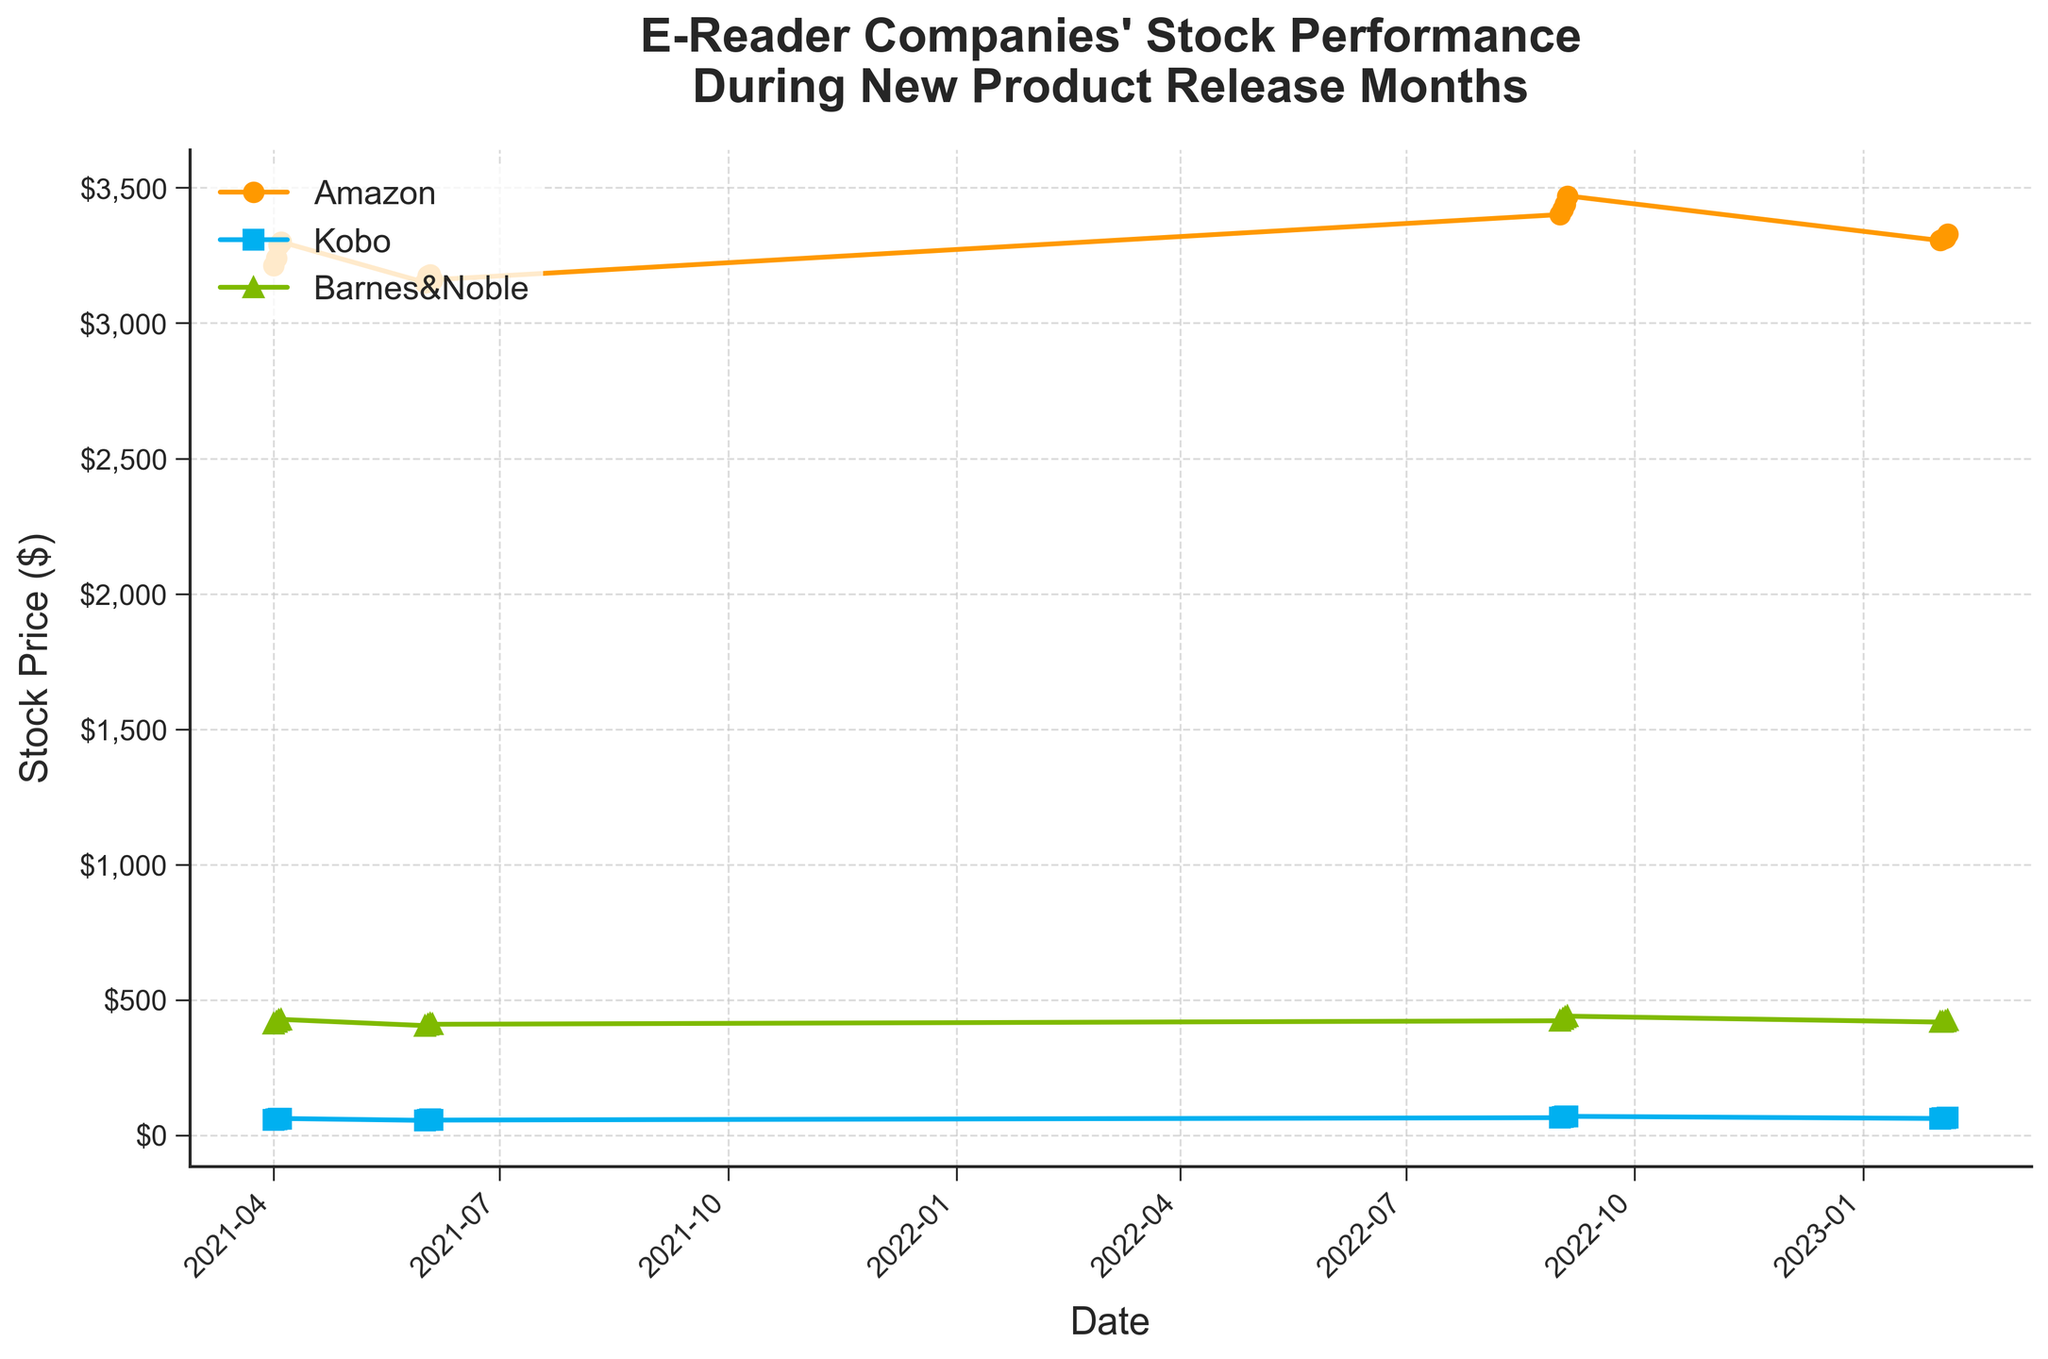How many companies are compared in the plot? The plot compares three e-reader companies' stock performances. You can see from the legend that the companies are Amazon, Kobo, and Barnes & Noble.
Answer: 3 What is the overall trend for Amazon's stock price during the dates shown? Amazon's stock price shows significant fluctuations with a rise in early April 2021, a drop in June 2021, a peak in September 2022, and a slight upwards movement in February 2023.
Answer: Fluctuating with a peak in September 2022 Which company had the highest stock price on September 3, 2022? By observing the plot on the date September 3, 2022, Amazon has the highest stock price which is around $3440 compared to Kobo and Barnes & Noble.
Answer: Amazon Between June 1, 2021, and June 4, 2021, did Kobo's stock price experience an increase or decrease? From June 1, 2021, to June 4, 2021, Kobo's stock price shows a slight increase from 55 to 56. The plot line for Kobo trends upwards during this period.
Answer: Increase During the time frame shown in the plot, when did Barnes & Noble's stock price briefly dip before returning to a higher value? Barnes & Noble's stock price dipped in June 2021 before returning to a higher value later on.
Answer: June 2021 Which company had the most significant stock price growth between April 1, 2021, and September 1, 2022? By comparing the curves, Amazon's stock price increased from about 3212 to 3401, showing significant growth. The other two had less pronounced growths.
Answer: Amazon Comparing the stock prices on April 4, 2021, and February 4, 2023, which company's stock decreased? By observing the plotted data points, only Amazon's stock decreased from about 3300 on April 4, 2021, to about 3330 on February 4, 2023.
Answer: Amazon Which stock price peaked in September 2022? From the plotted data, all three companies (Amazon, Kobo, Barnes & Noble) show their highest stock prices around September 1, 2022.
Answer: All three What is the average stock price of Kobo on April 1, 2021, and February 1, 2023? To find the average, add the prices on these dates (56 + 62 = 118) and divide by 2, resulting in 118/2 = 59.
Answer: 59 On February 2, 2023, how much higher was Amazon's stock price compared to Kobo's? The plot shows Amazon's stock price at 3310 and Kobo's at 63. The difference is 3310 - 63 = 3247.
Answer: 3247 